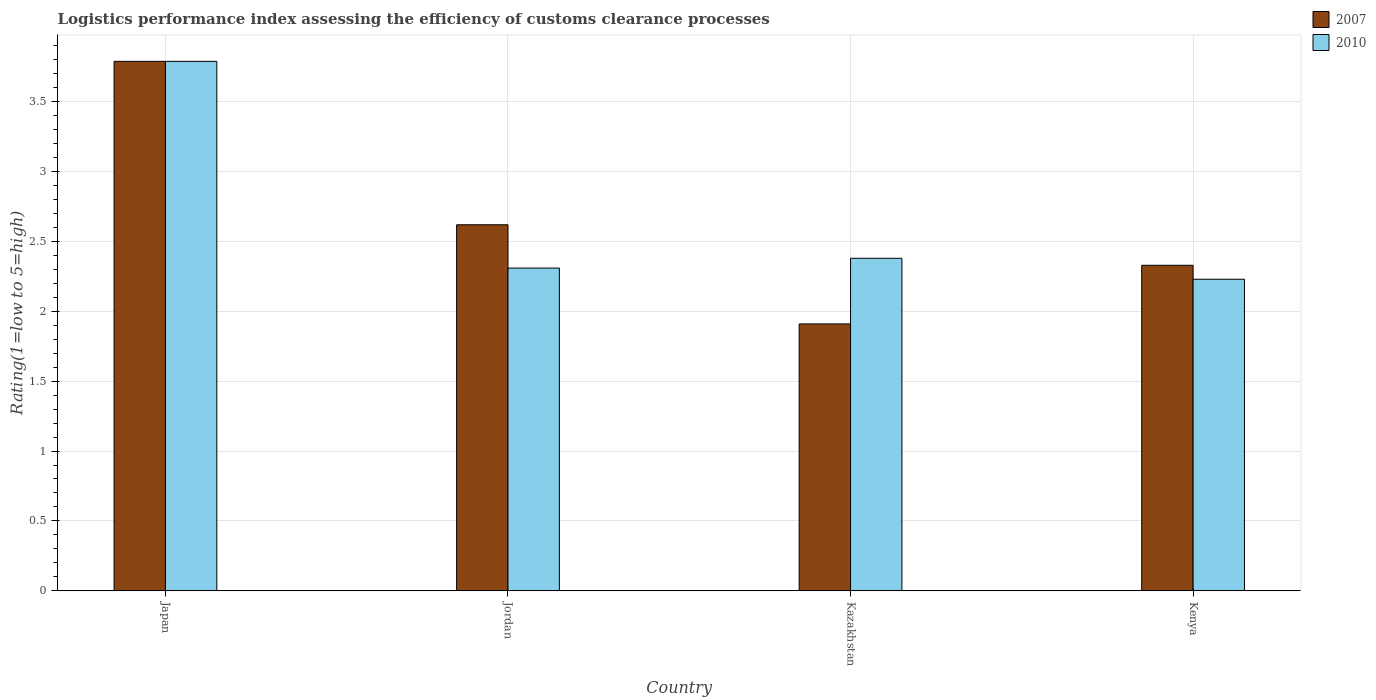How many different coloured bars are there?
Your answer should be compact. 2. How many groups of bars are there?
Provide a succinct answer. 4. Are the number of bars on each tick of the X-axis equal?
Provide a succinct answer. Yes. How many bars are there on the 3rd tick from the right?
Your answer should be compact. 2. What is the label of the 4th group of bars from the left?
Make the answer very short. Kenya. What is the Logistic performance index in 2007 in Jordan?
Your answer should be compact. 2.62. Across all countries, what is the maximum Logistic performance index in 2007?
Offer a very short reply. 3.79. Across all countries, what is the minimum Logistic performance index in 2007?
Offer a terse response. 1.91. In which country was the Logistic performance index in 2010 minimum?
Keep it short and to the point. Kenya. What is the total Logistic performance index in 2010 in the graph?
Offer a terse response. 10.71. What is the difference between the Logistic performance index in 2007 in Japan and that in Jordan?
Make the answer very short. 1.17. What is the difference between the Logistic performance index in 2007 in Kenya and the Logistic performance index in 2010 in Kazakhstan?
Give a very brief answer. -0.05. What is the average Logistic performance index in 2007 per country?
Make the answer very short. 2.66. What is the difference between the Logistic performance index of/in 2007 and Logistic performance index of/in 2010 in Kazakhstan?
Offer a terse response. -0.47. What is the ratio of the Logistic performance index in 2010 in Japan to that in Kazakhstan?
Your answer should be compact. 1.59. Is the Logistic performance index in 2010 in Japan less than that in Jordan?
Provide a succinct answer. No. What is the difference between the highest and the second highest Logistic performance index in 2007?
Provide a short and direct response. -1.17. What is the difference between the highest and the lowest Logistic performance index in 2007?
Provide a short and direct response. 1.88. How many bars are there?
Make the answer very short. 8. How many countries are there in the graph?
Your answer should be compact. 4. What is the difference between two consecutive major ticks on the Y-axis?
Keep it short and to the point. 0.5. Are the values on the major ticks of Y-axis written in scientific E-notation?
Your answer should be compact. No. Does the graph contain any zero values?
Your answer should be compact. No. Where does the legend appear in the graph?
Your response must be concise. Top right. How many legend labels are there?
Give a very brief answer. 2. What is the title of the graph?
Give a very brief answer. Logistics performance index assessing the efficiency of customs clearance processes. Does "1961" appear as one of the legend labels in the graph?
Ensure brevity in your answer.  No. What is the label or title of the X-axis?
Make the answer very short. Country. What is the label or title of the Y-axis?
Provide a short and direct response. Rating(1=low to 5=high). What is the Rating(1=low to 5=high) of 2007 in Japan?
Your response must be concise. 3.79. What is the Rating(1=low to 5=high) in 2010 in Japan?
Keep it short and to the point. 3.79. What is the Rating(1=low to 5=high) of 2007 in Jordan?
Make the answer very short. 2.62. What is the Rating(1=low to 5=high) in 2010 in Jordan?
Ensure brevity in your answer.  2.31. What is the Rating(1=low to 5=high) of 2007 in Kazakhstan?
Keep it short and to the point. 1.91. What is the Rating(1=low to 5=high) in 2010 in Kazakhstan?
Offer a very short reply. 2.38. What is the Rating(1=low to 5=high) in 2007 in Kenya?
Offer a very short reply. 2.33. What is the Rating(1=low to 5=high) of 2010 in Kenya?
Offer a very short reply. 2.23. Across all countries, what is the maximum Rating(1=low to 5=high) of 2007?
Provide a succinct answer. 3.79. Across all countries, what is the maximum Rating(1=low to 5=high) of 2010?
Ensure brevity in your answer.  3.79. Across all countries, what is the minimum Rating(1=low to 5=high) of 2007?
Offer a terse response. 1.91. Across all countries, what is the minimum Rating(1=low to 5=high) of 2010?
Your response must be concise. 2.23. What is the total Rating(1=low to 5=high) of 2007 in the graph?
Your answer should be compact. 10.65. What is the total Rating(1=low to 5=high) in 2010 in the graph?
Offer a very short reply. 10.71. What is the difference between the Rating(1=low to 5=high) in 2007 in Japan and that in Jordan?
Your response must be concise. 1.17. What is the difference between the Rating(1=low to 5=high) in 2010 in Japan and that in Jordan?
Make the answer very short. 1.48. What is the difference between the Rating(1=low to 5=high) of 2007 in Japan and that in Kazakhstan?
Give a very brief answer. 1.88. What is the difference between the Rating(1=low to 5=high) of 2010 in Japan and that in Kazakhstan?
Your answer should be very brief. 1.41. What is the difference between the Rating(1=low to 5=high) in 2007 in Japan and that in Kenya?
Provide a succinct answer. 1.46. What is the difference between the Rating(1=low to 5=high) in 2010 in Japan and that in Kenya?
Give a very brief answer. 1.56. What is the difference between the Rating(1=low to 5=high) of 2007 in Jordan and that in Kazakhstan?
Your answer should be compact. 0.71. What is the difference between the Rating(1=low to 5=high) of 2010 in Jordan and that in Kazakhstan?
Your answer should be very brief. -0.07. What is the difference between the Rating(1=low to 5=high) in 2007 in Jordan and that in Kenya?
Provide a short and direct response. 0.29. What is the difference between the Rating(1=low to 5=high) of 2010 in Jordan and that in Kenya?
Provide a succinct answer. 0.08. What is the difference between the Rating(1=low to 5=high) in 2007 in Kazakhstan and that in Kenya?
Offer a very short reply. -0.42. What is the difference between the Rating(1=low to 5=high) in 2010 in Kazakhstan and that in Kenya?
Give a very brief answer. 0.15. What is the difference between the Rating(1=low to 5=high) of 2007 in Japan and the Rating(1=low to 5=high) of 2010 in Jordan?
Ensure brevity in your answer.  1.48. What is the difference between the Rating(1=low to 5=high) of 2007 in Japan and the Rating(1=low to 5=high) of 2010 in Kazakhstan?
Your response must be concise. 1.41. What is the difference between the Rating(1=low to 5=high) in 2007 in Japan and the Rating(1=low to 5=high) in 2010 in Kenya?
Offer a terse response. 1.56. What is the difference between the Rating(1=low to 5=high) in 2007 in Jordan and the Rating(1=low to 5=high) in 2010 in Kazakhstan?
Provide a short and direct response. 0.24. What is the difference between the Rating(1=low to 5=high) of 2007 in Jordan and the Rating(1=low to 5=high) of 2010 in Kenya?
Offer a very short reply. 0.39. What is the difference between the Rating(1=low to 5=high) of 2007 in Kazakhstan and the Rating(1=low to 5=high) of 2010 in Kenya?
Offer a very short reply. -0.32. What is the average Rating(1=low to 5=high) in 2007 per country?
Your response must be concise. 2.66. What is the average Rating(1=low to 5=high) of 2010 per country?
Provide a short and direct response. 2.68. What is the difference between the Rating(1=low to 5=high) in 2007 and Rating(1=low to 5=high) in 2010 in Jordan?
Provide a succinct answer. 0.31. What is the difference between the Rating(1=low to 5=high) of 2007 and Rating(1=low to 5=high) of 2010 in Kazakhstan?
Offer a very short reply. -0.47. What is the ratio of the Rating(1=low to 5=high) of 2007 in Japan to that in Jordan?
Your answer should be very brief. 1.45. What is the ratio of the Rating(1=low to 5=high) of 2010 in Japan to that in Jordan?
Offer a terse response. 1.64. What is the ratio of the Rating(1=low to 5=high) of 2007 in Japan to that in Kazakhstan?
Your response must be concise. 1.98. What is the ratio of the Rating(1=low to 5=high) in 2010 in Japan to that in Kazakhstan?
Give a very brief answer. 1.59. What is the ratio of the Rating(1=low to 5=high) of 2007 in Japan to that in Kenya?
Your answer should be compact. 1.63. What is the ratio of the Rating(1=low to 5=high) in 2010 in Japan to that in Kenya?
Your response must be concise. 1.7. What is the ratio of the Rating(1=low to 5=high) in 2007 in Jordan to that in Kazakhstan?
Your answer should be compact. 1.37. What is the ratio of the Rating(1=low to 5=high) in 2010 in Jordan to that in Kazakhstan?
Your response must be concise. 0.97. What is the ratio of the Rating(1=low to 5=high) in 2007 in Jordan to that in Kenya?
Your answer should be compact. 1.12. What is the ratio of the Rating(1=low to 5=high) of 2010 in Jordan to that in Kenya?
Keep it short and to the point. 1.04. What is the ratio of the Rating(1=low to 5=high) in 2007 in Kazakhstan to that in Kenya?
Your answer should be compact. 0.82. What is the ratio of the Rating(1=low to 5=high) of 2010 in Kazakhstan to that in Kenya?
Your response must be concise. 1.07. What is the difference between the highest and the second highest Rating(1=low to 5=high) of 2007?
Provide a succinct answer. 1.17. What is the difference between the highest and the second highest Rating(1=low to 5=high) in 2010?
Offer a terse response. 1.41. What is the difference between the highest and the lowest Rating(1=low to 5=high) in 2007?
Your answer should be very brief. 1.88. What is the difference between the highest and the lowest Rating(1=low to 5=high) of 2010?
Your response must be concise. 1.56. 